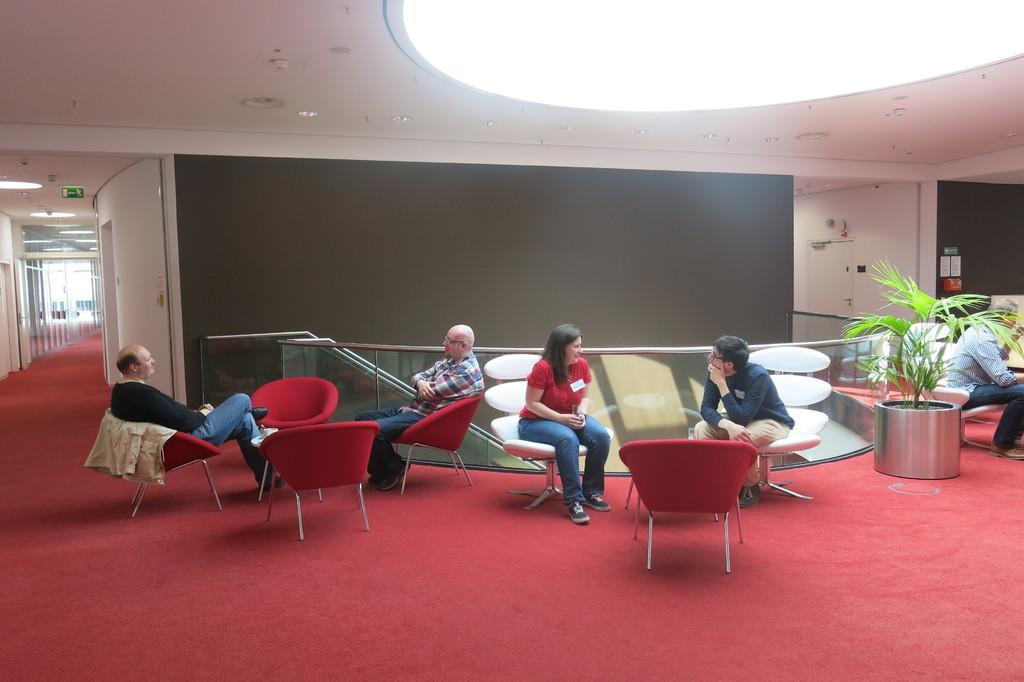How would you summarize this image in a sentence or two? At the top we can see ceiling and light. This is a exit board. Here we can see a red carpet on the floor. This is a plant. We can see persons sitting on chairs. This is a door. 